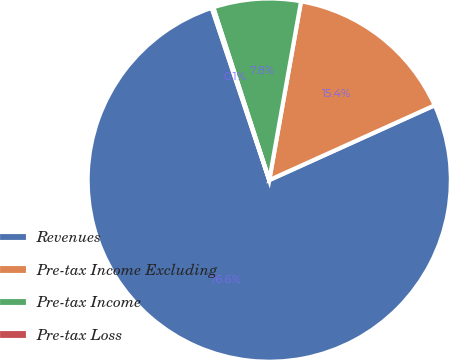Convert chart. <chart><loc_0><loc_0><loc_500><loc_500><pie_chart><fcel>Revenues<fcel>Pre-tax Income Excluding<fcel>Pre-tax Income<fcel>Pre-tax Loss<nl><fcel>76.63%<fcel>15.44%<fcel>7.79%<fcel>0.14%<nl></chart> 